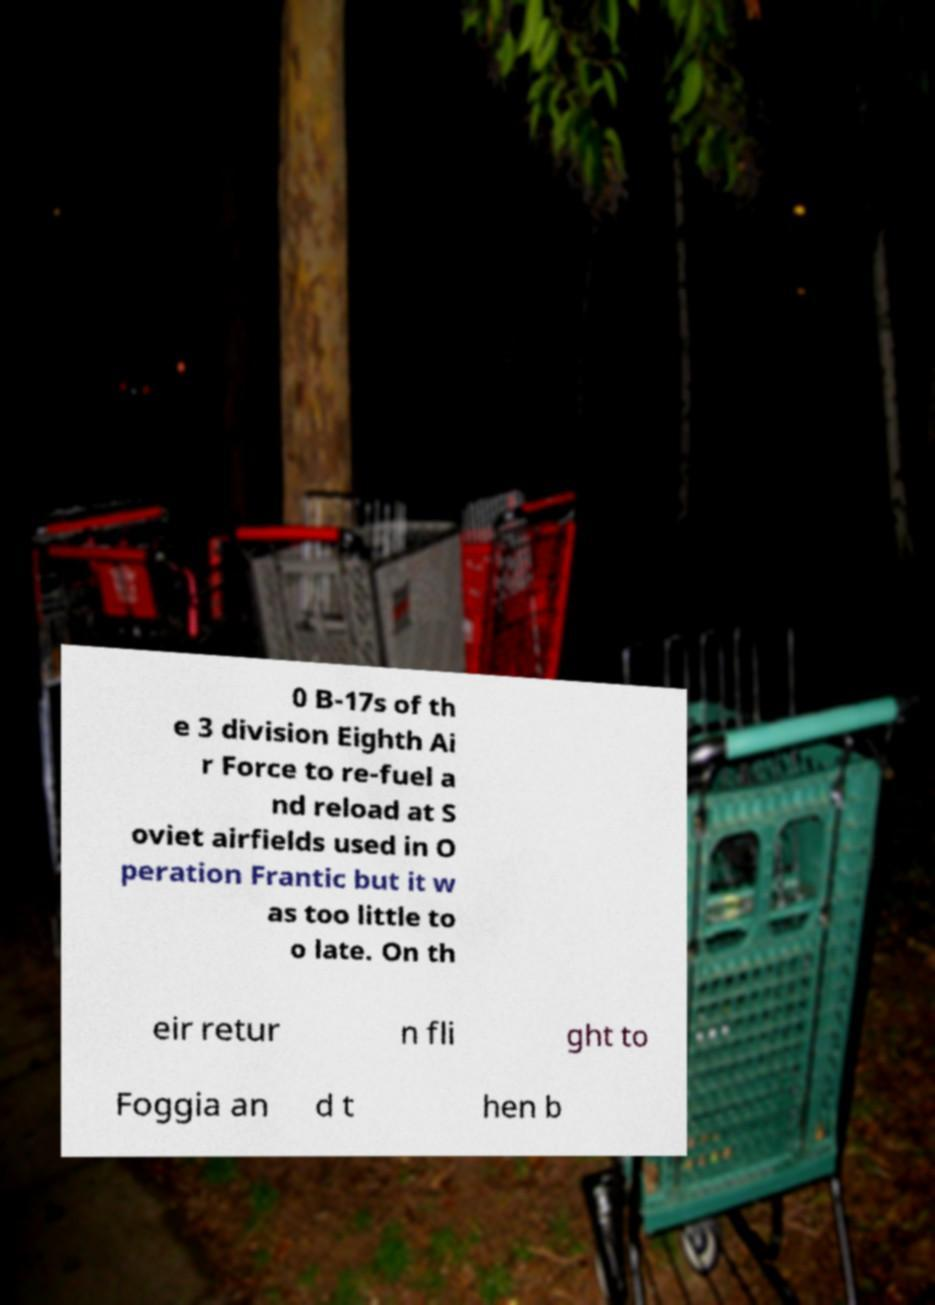Could you assist in decoding the text presented in this image and type it out clearly? 0 B-17s of th e 3 division Eighth Ai r Force to re-fuel a nd reload at S oviet airfields used in O peration Frantic but it w as too little to o late. On th eir retur n fli ght to Foggia an d t hen b 